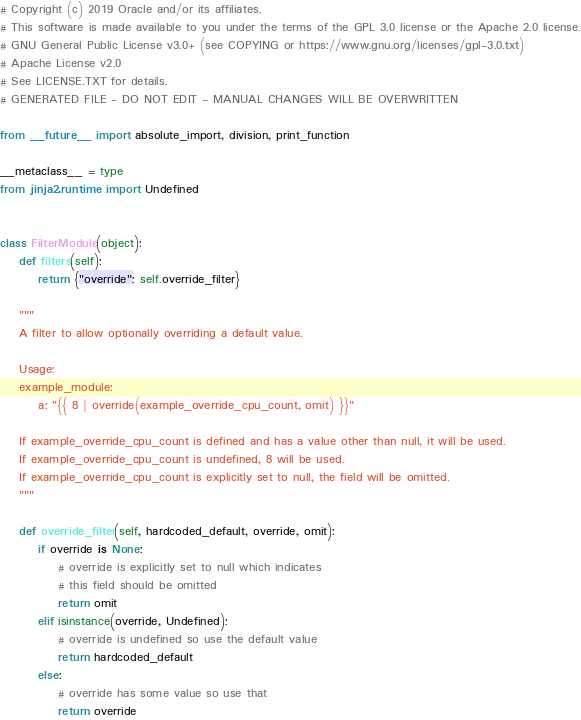<code> <loc_0><loc_0><loc_500><loc_500><_Python_># Copyright (c) 2019 Oracle and/or its affiliates.
# This software is made available to you under the terms of the GPL 3.0 license or the Apache 2.0 license.
# GNU General Public License v3.0+ (see COPYING or https://www.gnu.org/licenses/gpl-3.0.txt)
# Apache License v2.0
# See LICENSE.TXT for details.
# GENERATED FILE - DO NOT EDIT - MANUAL CHANGES WILL BE OVERWRITTEN

from __future__ import absolute_import, division, print_function

__metaclass__ = type
from jinja2.runtime import Undefined


class FilterModule(object):
    def filters(self):
        return {"override": self.override_filter}

    """
    A filter to allow optionally overriding a default value.

    Usage:
    example_module:
        a: "{{ 8 | override(example_override_cpu_count, omit) }}"

    If example_override_cpu_count is defined and has a value other than null, it will be used.
    If example_override_cpu_count is undefined, 8 will be used.
    If example_override_cpu_count is explicitly set to null, the field will be omitted.
    """

    def override_filter(self, hardcoded_default, override, omit):
        if override is None:
            # override is explicitly set to null which indicates
            # this field should be omitted
            return omit
        elif isinstance(override, Undefined):
            # override is undefined so use the default value
            return hardcoded_default
        else:
            # override has some value so use that
            return override
</code> 